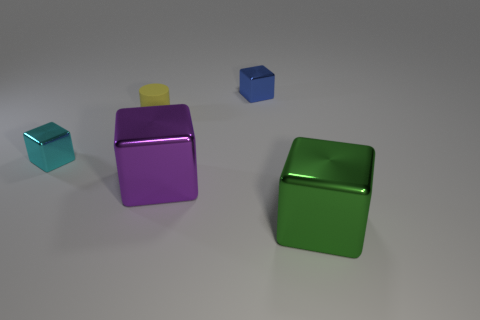Subtract all small cyan metal cubes. How many cubes are left? 3 Subtract all cubes. How many objects are left? 1 Add 5 large things. How many objects exist? 10 Subtract all green blocks. How many blocks are left? 3 Subtract all gray spheres. How many green blocks are left? 1 Subtract all tiny yellow matte cylinders. Subtract all red metallic spheres. How many objects are left? 4 Add 4 large shiny blocks. How many large shiny blocks are left? 6 Add 5 blocks. How many blocks exist? 9 Subtract 0 cyan balls. How many objects are left? 5 Subtract 1 cylinders. How many cylinders are left? 0 